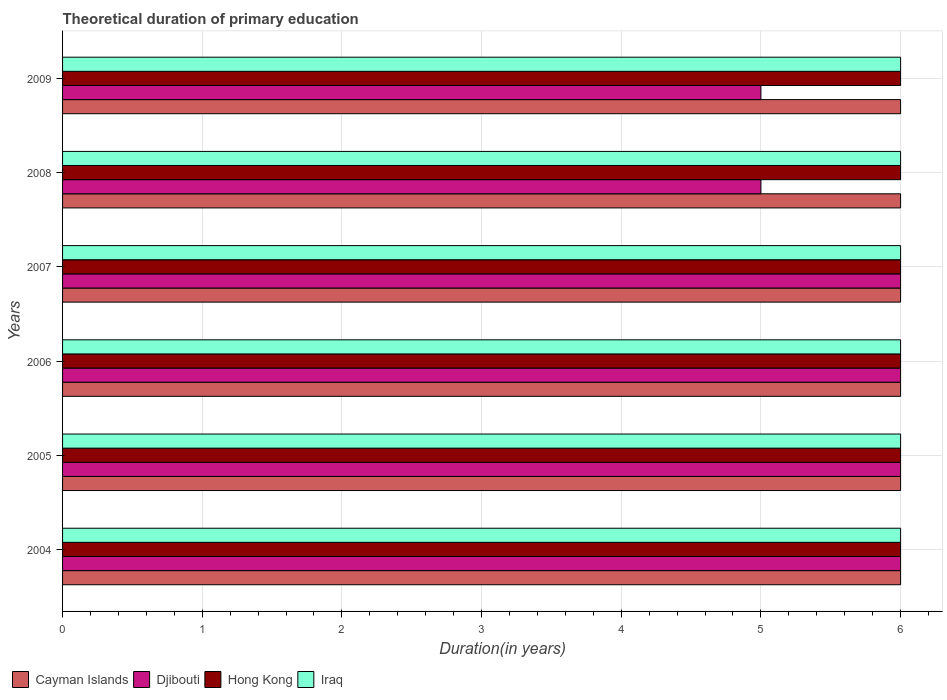How many different coloured bars are there?
Ensure brevity in your answer.  4. Are the number of bars on each tick of the Y-axis equal?
Offer a terse response. Yes. How many bars are there on the 4th tick from the bottom?
Ensure brevity in your answer.  4. What is the label of the 5th group of bars from the top?
Your answer should be very brief. 2005. In how many cases, is the number of bars for a given year not equal to the number of legend labels?
Provide a short and direct response. 0. What is the total theoretical duration of primary education in Cayman Islands in 2008?
Provide a succinct answer. 6. Across all years, what is the minimum total theoretical duration of primary education in Hong Kong?
Ensure brevity in your answer.  6. In which year was the total theoretical duration of primary education in Hong Kong minimum?
Offer a very short reply. 2004. What is the total total theoretical duration of primary education in Djibouti in the graph?
Keep it short and to the point. 34. What is the difference between the total theoretical duration of primary education in Iraq in 2004 and the total theoretical duration of primary education in Djibouti in 2006?
Your answer should be compact. 0. What is the average total theoretical duration of primary education in Cayman Islands per year?
Give a very brief answer. 6. In the year 2008, what is the difference between the total theoretical duration of primary education in Hong Kong and total theoretical duration of primary education in Djibouti?
Provide a succinct answer. 1. What is the ratio of the total theoretical duration of primary education in Hong Kong in 2007 to that in 2009?
Make the answer very short. 1. Is the total theoretical duration of primary education in Djibouti in 2004 less than that in 2005?
Give a very brief answer. No. Is the difference between the total theoretical duration of primary education in Hong Kong in 2004 and 2009 greater than the difference between the total theoretical duration of primary education in Djibouti in 2004 and 2009?
Ensure brevity in your answer.  No. What is the difference between the highest and the second highest total theoretical duration of primary education in Hong Kong?
Your answer should be compact. 0. What is the difference between the highest and the lowest total theoretical duration of primary education in Cayman Islands?
Keep it short and to the point. 0. In how many years, is the total theoretical duration of primary education in Cayman Islands greater than the average total theoretical duration of primary education in Cayman Islands taken over all years?
Provide a short and direct response. 0. What does the 1st bar from the top in 2009 represents?
Your response must be concise. Iraq. What does the 1st bar from the bottom in 2006 represents?
Make the answer very short. Cayman Islands. Does the graph contain any zero values?
Provide a succinct answer. No. Does the graph contain grids?
Keep it short and to the point. Yes. How many legend labels are there?
Keep it short and to the point. 4. What is the title of the graph?
Offer a very short reply. Theoretical duration of primary education. What is the label or title of the X-axis?
Offer a very short reply. Duration(in years). What is the label or title of the Y-axis?
Provide a succinct answer. Years. What is the Duration(in years) in Cayman Islands in 2004?
Provide a succinct answer. 6. What is the Duration(in years) of Djibouti in 2004?
Offer a terse response. 6. What is the Duration(in years) in Cayman Islands in 2005?
Your answer should be very brief. 6. What is the Duration(in years) of Hong Kong in 2005?
Ensure brevity in your answer.  6. What is the Duration(in years) in Iraq in 2005?
Your answer should be very brief. 6. What is the Duration(in years) of Djibouti in 2006?
Keep it short and to the point. 6. What is the Duration(in years) of Hong Kong in 2006?
Offer a terse response. 6. What is the Duration(in years) of Iraq in 2006?
Provide a succinct answer. 6. What is the Duration(in years) of Hong Kong in 2007?
Provide a succinct answer. 6. What is the Duration(in years) in Cayman Islands in 2008?
Your answer should be compact. 6. What is the Duration(in years) of Djibouti in 2008?
Provide a succinct answer. 5. What is the Duration(in years) in Hong Kong in 2008?
Your answer should be very brief. 6. What is the Duration(in years) of Iraq in 2008?
Offer a terse response. 6. What is the Duration(in years) in Cayman Islands in 2009?
Keep it short and to the point. 6. What is the Duration(in years) of Iraq in 2009?
Offer a terse response. 6. Across all years, what is the minimum Duration(in years) in Djibouti?
Give a very brief answer. 5. Across all years, what is the minimum Duration(in years) of Hong Kong?
Keep it short and to the point. 6. Across all years, what is the minimum Duration(in years) of Iraq?
Offer a very short reply. 6. What is the total Duration(in years) in Djibouti in the graph?
Provide a succinct answer. 34. What is the total Duration(in years) in Hong Kong in the graph?
Provide a short and direct response. 36. What is the total Duration(in years) of Iraq in the graph?
Give a very brief answer. 36. What is the difference between the Duration(in years) of Cayman Islands in 2004 and that in 2005?
Provide a short and direct response. 0. What is the difference between the Duration(in years) in Djibouti in 2004 and that in 2005?
Offer a terse response. 0. What is the difference between the Duration(in years) of Hong Kong in 2004 and that in 2005?
Provide a succinct answer. 0. What is the difference between the Duration(in years) of Iraq in 2004 and that in 2005?
Your response must be concise. 0. What is the difference between the Duration(in years) of Djibouti in 2004 and that in 2006?
Provide a short and direct response. 0. What is the difference between the Duration(in years) of Iraq in 2004 and that in 2008?
Provide a short and direct response. 0. What is the difference between the Duration(in years) in Cayman Islands in 2004 and that in 2009?
Your answer should be compact. 0. What is the difference between the Duration(in years) in Djibouti in 2004 and that in 2009?
Your answer should be very brief. 1. What is the difference between the Duration(in years) in Hong Kong in 2004 and that in 2009?
Your answer should be compact. 0. What is the difference between the Duration(in years) in Cayman Islands in 2005 and that in 2006?
Your answer should be compact. 0. What is the difference between the Duration(in years) in Djibouti in 2005 and that in 2006?
Provide a succinct answer. 0. What is the difference between the Duration(in years) in Hong Kong in 2005 and that in 2006?
Give a very brief answer. 0. What is the difference between the Duration(in years) in Iraq in 2005 and that in 2006?
Keep it short and to the point. 0. What is the difference between the Duration(in years) of Hong Kong in 2005 and that in 2007?
Offer a terse response. 0. What is the difference between the Duration(in years) of Iraq in 2005 and that in 2007?
Your answer should be very brief. 0. What is the difference between the Duration(in years) of Djibouti in 2005 and that in 2008?
Provide a short and direct response. 1. What is the difference between the Duration(in years) of Hong Kong in 2005 and that in 2008?
Offer a terse response. 0. What is the difference between the Duration(in years) in Iraq in 2005 and that in 2008?
Ensure brevity in your answer.  0. What is the difference between the Duration(in years) in Hong Kong in 2005 and that in 2009?
Provide a succinct answer. 0. What is the difference between the Duration(in years) in Djibouti in 2006 and that in 2008?
Provide a succinct answer. 1. What is the difference between the Duration(in years) of Hong Kong in 2006 and that in 2009?
Keep it short and to the point. 0. What is the difference between the Duration(in years) of Djibouti in 2007 and that in 2009?
Offer a terse response. 1. What is the difference between the Duration(in years) in Hong Kong in 2007 and that in 2009?
Your answer should be compact. 0. What is the difference between the Duration(in years) in Iraq in 2007 and that in 2009?
Make the answer very short. 0. What is the difference between the Duration(in years) in Djibouti in 2008 and that in 2009?
Offer a terse response. 0. What is the difference between the Duration(in years) in Cayman Islands in 2004 and the Duration(in years) in Hong Kong in 2005?
Provide a short and direct response. 0. What is the difference between the Duration(in years) in Cayman Islands in 2004 and the Duration(in years) in Iraq in 2005?
Ensure brevity in your answer.  0. What is the difference between the Duration(in years) in Djibouti in 2004 and the Duration(in years) in Hong Kong in 2005?
Your answer should be compact. 0. What is the difference between the Duration(in years) in Djibouti in 2004 and the Duration(in years) in Iraq in 2005?
Your response must be concise. 0. What is the difference between the Duration(in years) of Cayman Islands in 2004 and the Duration(in years) of Hong Kong in 2006?
Provide a succinct answer. 0. What is the difference between the Duration(in years) of Cayman Islands in 2004 and the Duration(in years) of Iraq in 2006?
Your response must be concise. 0. What is the difference between the Duration(in years) of Hong Kong in 2004 and the Duration(in years) of Iraq in 2006?
Offer a very short reply. 0. What is the difference between the Duration(in years) in Cayman Islands in 2004 and the Duration(in years) in Djibouti in 2007?
Keep it short and to the point. 0. What is the difference between the Duration(in years) in Cayman Islands in 2004 and the Duration(in years) in Hong Kong in 2007?
Make the answer very short. 0. What is the difference between the Duration(in years) in Djibouti in 2004 and the Duration(in years) in Hong Kong in 2007?
Your answer should be compact. 0. What is the difference between the Duration(in years) in Djibouti in 2004 and the Duration(in years) in Iraq in 2007?
Keep it short and to the point. 0. What is the difference between the Duration(in years) in Hong Kong in 2004 and the Duration(in years) in Iraq in 2007?
Your response must be concise. 0. What is the difference between the Duration(in years) in Cayman Islands in 2004 and the Duration(in years) in Hong Kong in 2008?
Provide a short and direct response. 0. What is the difference between the Duration(in years) in Cayman Islands in 2004 and the Duration(in years) in Iraq in 2008?
Provide a succinct answer. 0. What is the difference between the Duration(in years) of Hong Kong in 2004 and the Duration(in years) of Iraq in 2008?
Make the answer very short. 0. What is the difference between the Duration(in years) in Cayman Islands in 2004 and the Duration(in years) in Hong Kong in 2009?
Provide a succinct answer. 0. What is the difference between the Duration(in years) of Djibouti in 2004 and the Duration(in years) of Hong Kong in 2009?
Provide a short and direct response. 0. What is the difference between the Duration(in years) of Cayman Islands in 2005 and the Duration(in years) of Iraq in 2006?
Give a very brief answer. 0. What is the difference between the Duration(in years) of Djibouti in 2005 and the Duration(in years) of Hong Kong in 2006?
Give a very brief answer. 0. What is the difference between the Duration(in years) in Djibouti in 2005 and the Duration(in years) in Iraq in 2006?
Ensure brevity in your answer.  0. What is the difference between the Duration(in years) in Hong Kong in 2005 and the Duration(in years) in Iraq in 2006?
Provide a succinct answer. 0. What is the difference between the Duration(in years) in Cayman Islands in 2005 and the Duration(in years) in Djibouti in 2007?
Provide a short and direct response. 0. What is the difference between the Duration(in years) of Cayman Islands in 2005 and the Duration(in years) of Hong Kong in 2007?
Keep it short and to the point. 0. What is the difference between the Duration(in years) in Djibouti in 2005 and the Duration(in years) in Iraq in 2007?
Offer a very short reply. 0. What is the difference between the Duration(in years) of Hong Kong in 2005 and the Duration(in years) of Iraq in 2007?
Make the answer very short. 0. What is the difference between the Duration(in years) of Cayman Islands in 2005 and the Duration(in years) of Hong Kong in 2008?
Offer a terse response. 0. What is the difference between the Duration(in years) of Djibouti in 2005 and the Duration(in years) of Iraq in 2008?
Provide a short and direct response. 0. What is the difference between the Duration(in years) in Hong Kong in 2005 and the Duration(in years) in Iraq in 2008?
Ensure brevity in your answer.  0. What is the difference between the Duration(in years) in Cayman Islands in 2005 and the Duration(in years) in Djibouti in 2009?
Your answer should be very brief. 1. What is the difference between the Duration(in years) in Cayman Islands in 2005 and the Duration(in years) in Hong Kong in 2009?
Your answer should be very brief. 0. What is the difference between the Duration(in years) of Hong Kong in 2005 and the Duration(in years) of Iraq in 2009?
Your response must be concise. 0. What is the difference between the Duration(in years) in Cayman Islands in 2006 and the Duration(in years) in Djibouti in 2007?
Offer a very short reply. 0. What is the difference between the Duration(in years) in Cayman Islands in 2006 and the Duration(in years) in Iraq in 2007?
Make the answer very short. 0. What is the difference between the Duration(in years) in Djibouti in 2006 and the Duration(in years) in Iraq in 2007?
Provide a short and direct response. 0. What is the difference between the Duration(in years) in Hong Kong in 2006 and the Duration(in years) in Iraq in 2008?
Your answer should be very brief. 0. What is the difference between the Duration(in years) of Cayman Islands in 2006 and the Duration(in years) of Iraq in 2009?
Make the answer very short. 0. What is the difference between the Duration(in years) of Djibouti in 2006 and the Duration(in years) of Iraq in 2009?
Give a very brief answer. 0. What is the difference between the Duration(in years) in Cayman Islands in 2007 and the Duration(in years) in Hong Kong in 2008?
Your answer should be compact. 0. What is the difference between the Duration(in years) in Cayman Islands in 2007 and the Duration(in years) in Iraq in 2008?
Give a very brief answer. 0. What is the difference between the Duration(in years) in Djibouti in 2007 and the Duration(in years) in Hong Kong in 2008?
Give a very brief answer. 0. What is the difference between the Duration(in years) in Cayman Islands in 2007 and the Duration(in years) in Iraq in 2009?
Your answer should be very brief. 0. What is the difference between the Duration(in years) of Djibouti in 2007 and the Duration(in years) of Hong Kong in 2009?
Your answer should be very brief. 0. What is the difference between the Duration(in years) of Djibouti in 2007 and the Duration(in years) of Iraq in 2009?
Ensure brevity in your answer.  0. What is the difference between the Duration(in years) of Cayman Islands in 2008 and the Duration(in years) of Iraq in 2009?
Provide a short and direct response. 0. What is the difference between the Duration(in years) in Djibouti in 2008 and the Duration(in years) in Iraq in 2009?
Offer a very short reply. -1. What is the difference between the Duration(in years) in Hong Kong in 2008 and the Duration(in years) in Iraq in 2009?
Provide a succinct answer. 0. What is the average Duration(in years) in Cayman Islands per year?
Provide a short and direct response. 6. What is the average Duration(in years) in Djibouti per year?
Your response must be concise. 5.67. In the year 2004, what is the difference between the Duration(in years) in Cayman Islands and Duration(in years) in Djibouti?
Your answer should be very brief. 0. In the year 2004, what is the difference between the Duration(in years) in Cayman Islands and Duration(in years) in Iraq?
Ensure brevity in your answer.  0. In the year 2004, what is the difference between the Duration(in years) of Djibouti and Duration(in years) of Iraq?
Offer a terse response. 0. In the year 2004, what is the difference between the Duration(in years) in Hong Kong and Duration(in years) in Iraq?
Provide a short and direct response. 0. In the year 2005, what is the difference between the Duration(in years) in Cayman Islands and Duration(in years) in Djibouti?
Your answer should be very brief. 0. In the year 2005, what is the difference between the Duration(in years) in Cayman Islands and Duration(in years) in Hong Kong?
Offer a terse response. 0. In the year 2005, what is the difference between the Duration(in years) of Djibouti and Duration(in years) of Iraq?
Your answer should be compact. 0. In the year 2005, what is the difference between the Duration(in years) in Hong Kong and Duration(in years) in Iraq?
Keep it short and to the point. 0. In the year 2006, what is the difference between the Duration(in years) of Cayman Islands and Duration(in years) of Hong Kong?
Make the answer very short. 0. In the year 2006, what is the difference between the Duration(in years) of Cayman Islands and Duration(in years) of Iraq?
Offer a very short reply. 0. In the year 2006, what is the difference between the Duration(in years) in Djibouti and Duration(in years) in Hong Kong?
Your response must be concise. 0. In the year 2007, what is the difference between the Duration(in years) of Cayman Islands and Duration(in years) of Djibouti?
Offer a very short reply. 0. In the year 2007, what is the difference between the Duration(in years) in Cayman Islands and Duration(in years) in Iraq?
Your response must be concise. 0. In the year 2007, what is the difference between the Duration(in years) of Djibouti and Duration(in years) of Hong Kong?
Offer a very short reply. 0. In the year 2008, what is the difference between the Duration(in years) of Cayman Islands and Duration(in years) of Djibouti?
Your response must be concise. 1. In the year 2009, what is the difference between the Duration(in years) in Cayman Islands and Duration(in years) in Iraq?
Keep it short and to the point. 0. In the year 2009, what is the difference between the Duration(in years) in Djibouti and Duration(in years) in Hong Kong?
Provide a succinct answer. -1. In the year 2009, what is the difference between the Duration(in years) in Hong Kong and Duration(in years) in Iraq?
Offer a very short reply. 0. What is the ratio of the Duration(in years) in Cayman Islands in 2004 to that in 2005?
Keep it short and to the point. 1. What is the ratio of the Duration(in years) of Djibouti in 2004 to that in 2005?
Offer a terse response. 1. What is the ratio of the Duration(in years) in Hong Kong in 2004 to that in 2007?
Provide a short and direct response. 1. What is the ratio of the Duration(in years) of Iraq in 2004 to that in 2008?
Make the answer very short. 1. What is the ratio of the Duration(in years) in Cayman Islands in 2004 to that in 2009?
Give a very brief answer. 1. What is the ratio of the Duration(in years) in Hong Kong in 2004 to that in 2009?
Provide a short and direct response. 1. What is the ratio of the Duration(in years) in Cayman Islands in 2005 to that in 2006?
Give a very brief answer. 1. What is the ratio of the Duration(in years) in Hong Kong in 2005 to that in 2006?
Offer a very short reply. 1. What is the ratio of the Duration(in years) of Cayman Islands in 2005 to that in 2007?
Your answer should be compact. 1. What is the ratio of the Duration(in years) of Hong Kong in 2005 to that in 2007?
Give a very brief answer. 1. What is the ratio of the Duration(in years) in Iraq in 2005 to that in 2007?
Give a very brief answer. 1. What is the ratio of the Duration(in years) of Djibouti in 2005 to that in 2009?
Offer a terse response. 1.2. What is the ratio of the Duration(in years) in Djibouti in 2006 to that in 2007?
Your answer should be very brief. 1. What is the ratio of the Duration(in years) in Hong Kong in 2006 to that in 2007?
Keep it short and to the point. 1. What is the ratio of the Duration(in years) of Cayman Islands in 2006 to that in 2008?
Keep it short and to the point. 1. What is the ratio of the Duration(in years) of Djibouti in 2006 to that in 2008?
Make the answer very short. 1.2. What is the ratio of the Duration(in years) in Cayman Islands in 2006 to that in 2009?
Your answer should be compact. 1. What is the ratio of the Duration(in years) in Djibouti in 2006 to that in 2009?
Make the answer very short. 1.2. What is the ratio of the Duration(in years) of Cayman Islands in 2007 to that in 2008?
Your response must be concise. 1. What is the ratio of the Duration(in years) of Djibouti in 2007 to that in 2008?
Make the answer very short. 1.2. What is the ratio of the Duration(in years) of Hong Kong in 2007 to that in 2008?
Keep it short and to the point. 1. What is the ratio of the Duration(in years) of Cayman Islands in 2007 to that in 2009?
Your response must be concise. 1. What is the ratio of the Duration(in years) of Hong Kong in 2007 to that in 2009?
Provide a short and direct response. 1. What is the ratio of the Duration(in years) in Iraq in 2007 to that in 2009?
Your answer should be very brief. 1. What is the ratio of the Duration(in years) of Hong Kong in 2008 to that in 2009?
Make the answer very short. 1. What is the ratio of the Duration(in years) in Iraq in 2008 to that in 2009?
Provide a short and direct response. 1. What is the difference between the highest and the second highest Duration(in years) in Djibouti?
Provide a succinct answer. 0. What is the difference between the highest and the lowest Duration(in years) of Djibouti?
Offer a terse response. 1. What is the difference between the highest and the lowest Duration(in years) of Iraq?
Give a very brief answer. 0. 